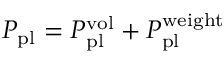<formula> <loc_0><loc_0><loc_500><loc_500>P _ { p l } = P _ { p l } ^ { v o l } + P _ { p l } ^ { w e i g h t }</formula> 